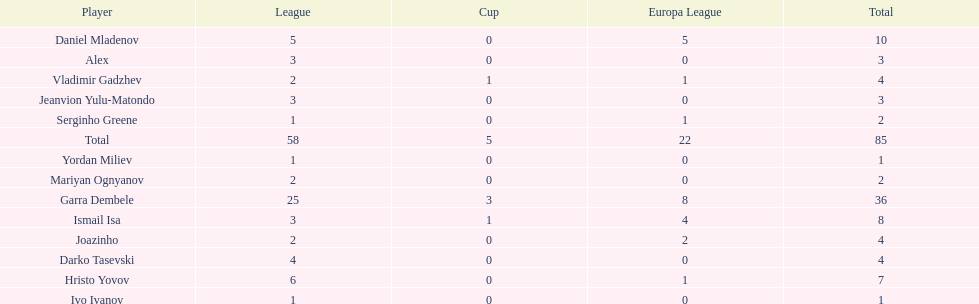Which total is higher, the europa league total or the league total? League. 